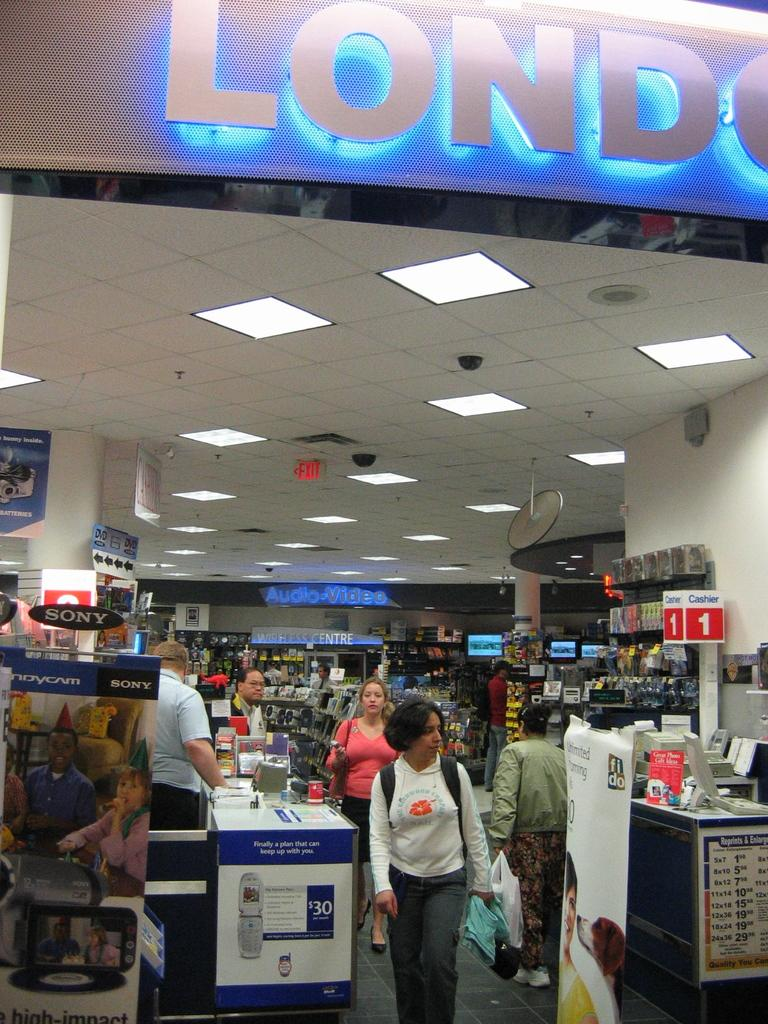<image>
Offer a succinct explanation of the picture presented. A store has an Audio-Video department way in the back. 